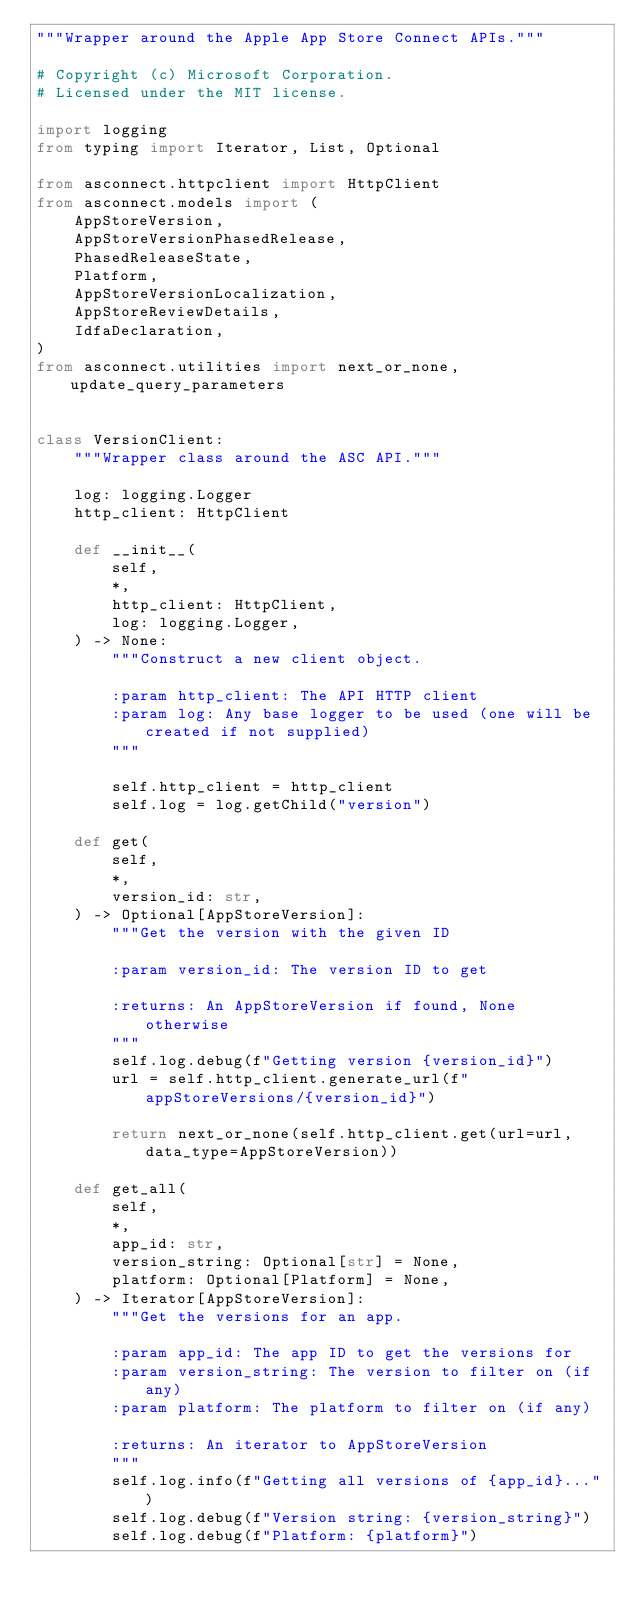<code> <loc_0><loc_0><loc_500><loc_500><_Python_>"""Wrapper around the Apple App Store Connect APIs."""

# Copyright (c) Microsoft Corporation.
# Licensed under the MIT license.

import logging
from typing import Iterator, List, Optional

from asconnect.httpclient import HttpClient
from asconnect.models import (
    AppStoreVersion,
    AppStoreVersionPhasedRelease,
    PhasedReleaseState,
    Platform,
    AppStoreVersionLocalization,
    AppStoreReviewDetails,
    IdfaDeclaration,
)
from asconnect.utilities import next_or_none, update_query_parameters


class VersionClient:
    """Wrapper class around the ASC API."""

    log: logging.Logger
    http_client: HttpClient

    def __init__(
        self,
        *,
        http_client: HttpClient,
        log: logging.Logger,
    ) -> None:
        """Construct a new client object.

        :param http_client: The API HTTP client
        :param log: Any base logger to be used (one will be created if not supplied)
        """

        self.http_client = http_client
        self.log = log.getChild("version")

    def get(
        self,
        *,
        version_id: str,
    ) -> Optional[AppStoreVersion]:
        """Get the version with the given ID

        :param version_id: The version ID to get

        :returns: An AppStoreVersion if found, None otherwise
        """
        self.log.debug(f"Getting version {version_id}")
        url = self.http_client.generate_url(f"appStoreVersions/{version_id}")

        return next_or_none(self.http_client.get(url=url, data_type=AppStoreVersion))

    def get_all(
        self,
        *,
        app_id: str,
        version_string: Optional[str] = None,
        platform: Optional[Platform] = None,
    ) -> Iterator[AppStoreVersion]:
        """Get the versions for an app.

        :param app_id: The app ID to get the versions for
        :param version_string: The version to filter on (if any)
        :param platform: The platform to filter on (if any)

        :returns: An iterator to AppStoreVersion
        """
        self.log.info(f"Getting all versions of {app_id}...")
        self.log.debug(f"Version string: {version_string}")
        self.log.debug(f"Platform: {platform}")
</code> 